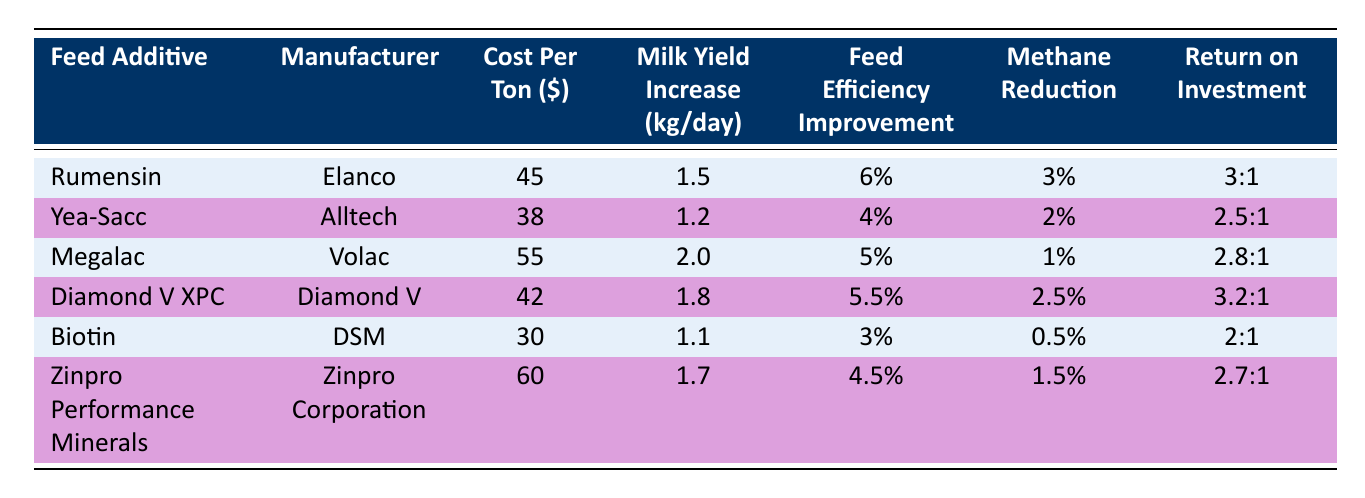What's the cost per ton of Rumensin? The table lists the cost per ton for each feed additive. For Rumensin, the value is directly stated in the "Cost Per Ton ($)" column.
Answer: 45 Which feed additive provides the highest milk yield increase? Looking at the "Milk Yield Increase (kg/day)" column, we find Megalac with a yield increase of 2.0, which is higher than all other additives.
Answer: Megalac What is the return on investment for Diamond V XPC? The return on investment for Diamond V XPC is listed in the "Return on Investment" column. Reading directly from the table shows it is 3.2:1.
Answer: 3.2:1 Which feed additive has the lowest cost per ton? To find the lowest cost per ton, we compare the values in the "Cost Per Ton ($)" column. Biotin has the lowest cost listed at 30.
Answer: Biotin If you were to average the milk yield increase for all feed additives, what would it be? First, we list the milk yield increases: 1.5 (Rumensin), 1.2 (Yea-Sacc), 2.0 (Megalac), 1.8 (Diamond V XPC), 1.1 (Biotin), and 1.7 (Zinpro Performance Minerals). Adding these gives 1.5 + 1.2 + 2.0 + 1.8 + 1.1 + 1.7 = 9.5. There are six additives, so the average is 9.5 / 6 = 1.58.
Answer: 1.58 Does Yea-Sacc have a higher feed efficiency improvement than Biotin? Comparing the values in the "Feed Efficiency Improvement" column shows Yea-Sacc has 4% while Biotin has 3%, thus Yea-Sacc has a higher improvement.
Answer: Yes Which feed additive has the highest methane reduction percentage? We compare the "Methane Reduction" column values. Rumensin has 3%, which is higher than all other additives listed.
Answer: Rumensin If you compare Rumensin and Diamond V XPC based on cost per ton and return on investment, which one is more cost-effective? Rumensin costs $45 per ton and has a 3:1 ROI. Diamond V XPC costs $42 per ton and has a 3.2:1 ROI. Although Rumensin has a higher ROI, Diamond V XPC is cheaper, suggesting it provides better value for the cost.
Answer: Diamond V XPC Is the feed efficiency improvement of Zinpro Performance Minerals greater than that of Yea-Sacc? Reviewing the "Feed Efficiency Improvement" column shows Zinpro Performance Minerals has 4.5%, while Yea-Sacc has 4%. Thus, Zinpro Performance Minerals has a greater improvement.
Answer: Yes 